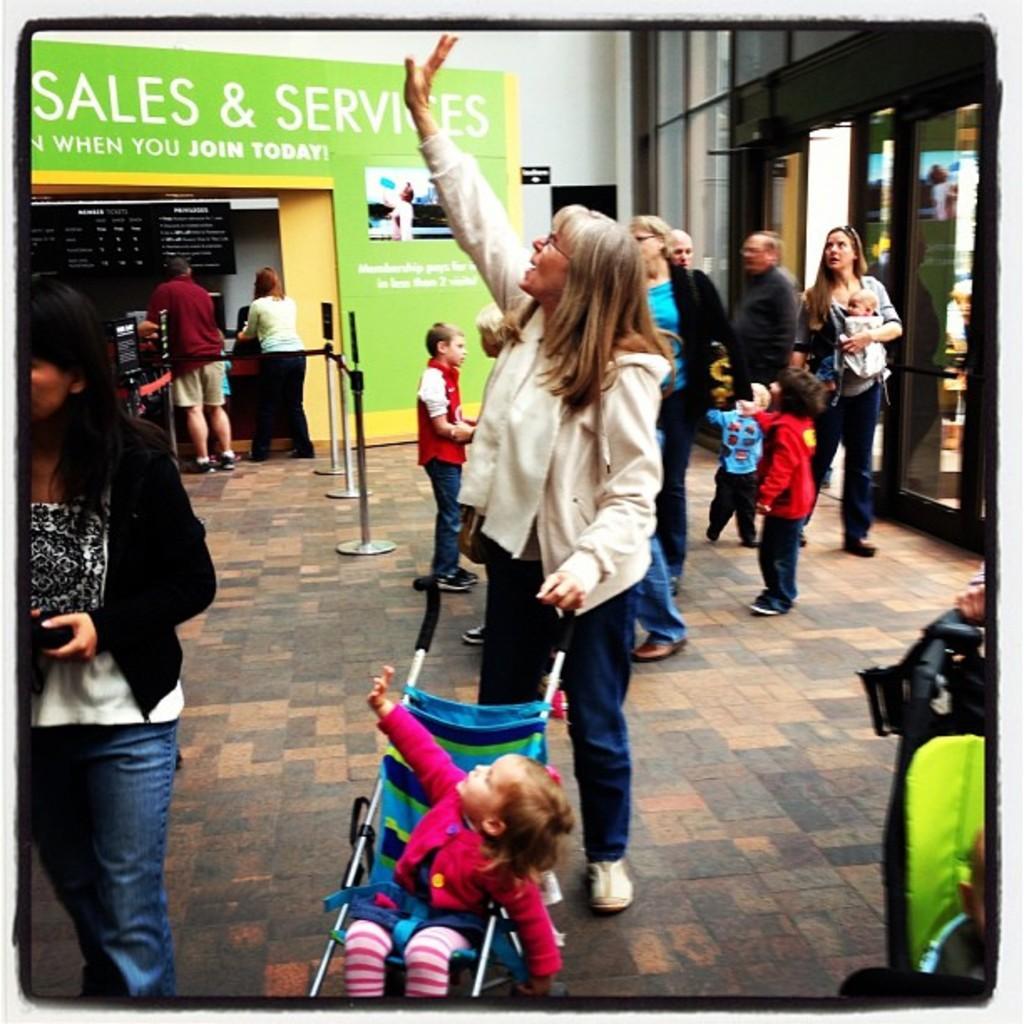In one or two sentences, can you explain what this image depicts? In this picture I can observe some people on the floor. On the bottom of the picture there is a baby sitting in the stroller. There are men and women in this picture. 